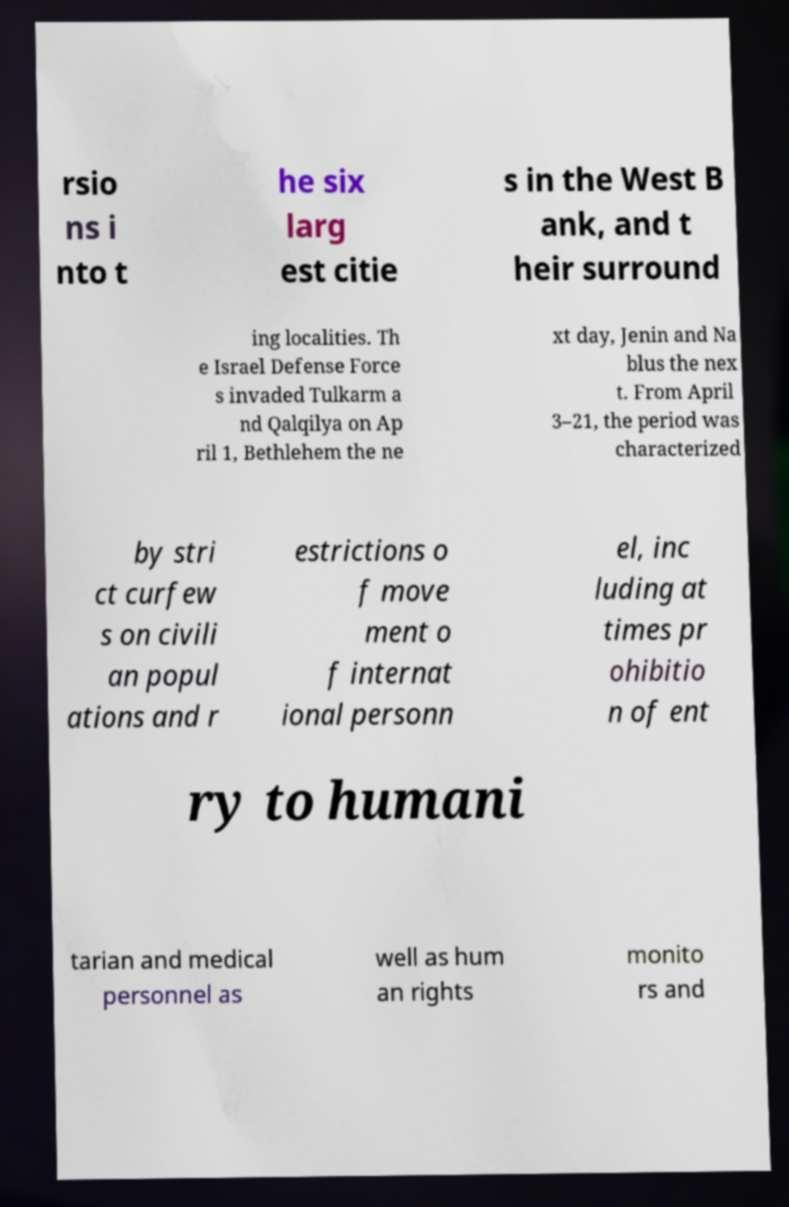Could you assist in decoding the text presented in this image and type it out clearly? rsio ns i nto t he six larg est citie s in the West B ank, and t heir surround ing localities. Th e Israel Defense Force s invaded Tulkarm a nd Qalqilya on Ap ril 1, Bethlehem the ne xt day, Jenin and Na blus the nex t. From April 3–21, the period was characterized by stri ct curfew s on civili an popul ations and r estrictions o f move ment o f internat ional personn el, inc luding at times pr ohibitio n of ent ry to humani tarian and medical personnel as well as hum an rights monito rs and 